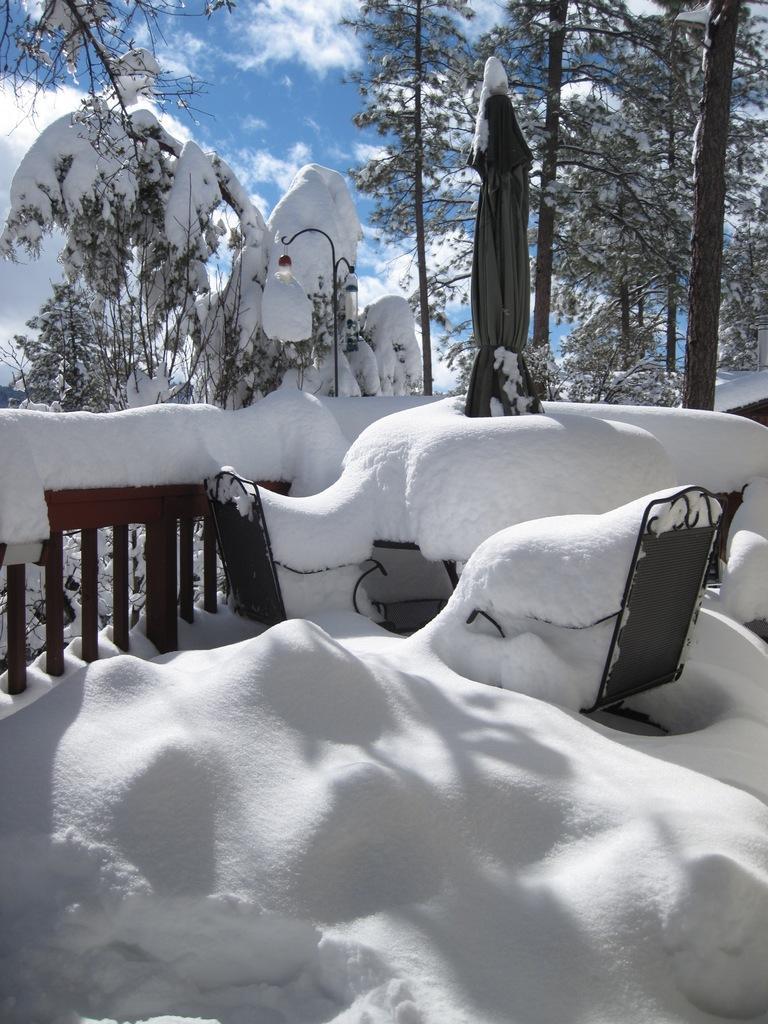How would you summarize this image in a sentence or two? In this image we can see some trees, snow, fence and some other objects, in the background, we can see the sky with clouds. 